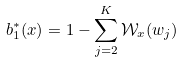<formula> <loc_0><loc_0><loc_500><loc_500>b _ { 1 } ^ { * } ( x ) = 1 - \sum _ { j = 2 } ^ { K } \mathcal { W } _ { x } ( w _ { j } )</formula> 